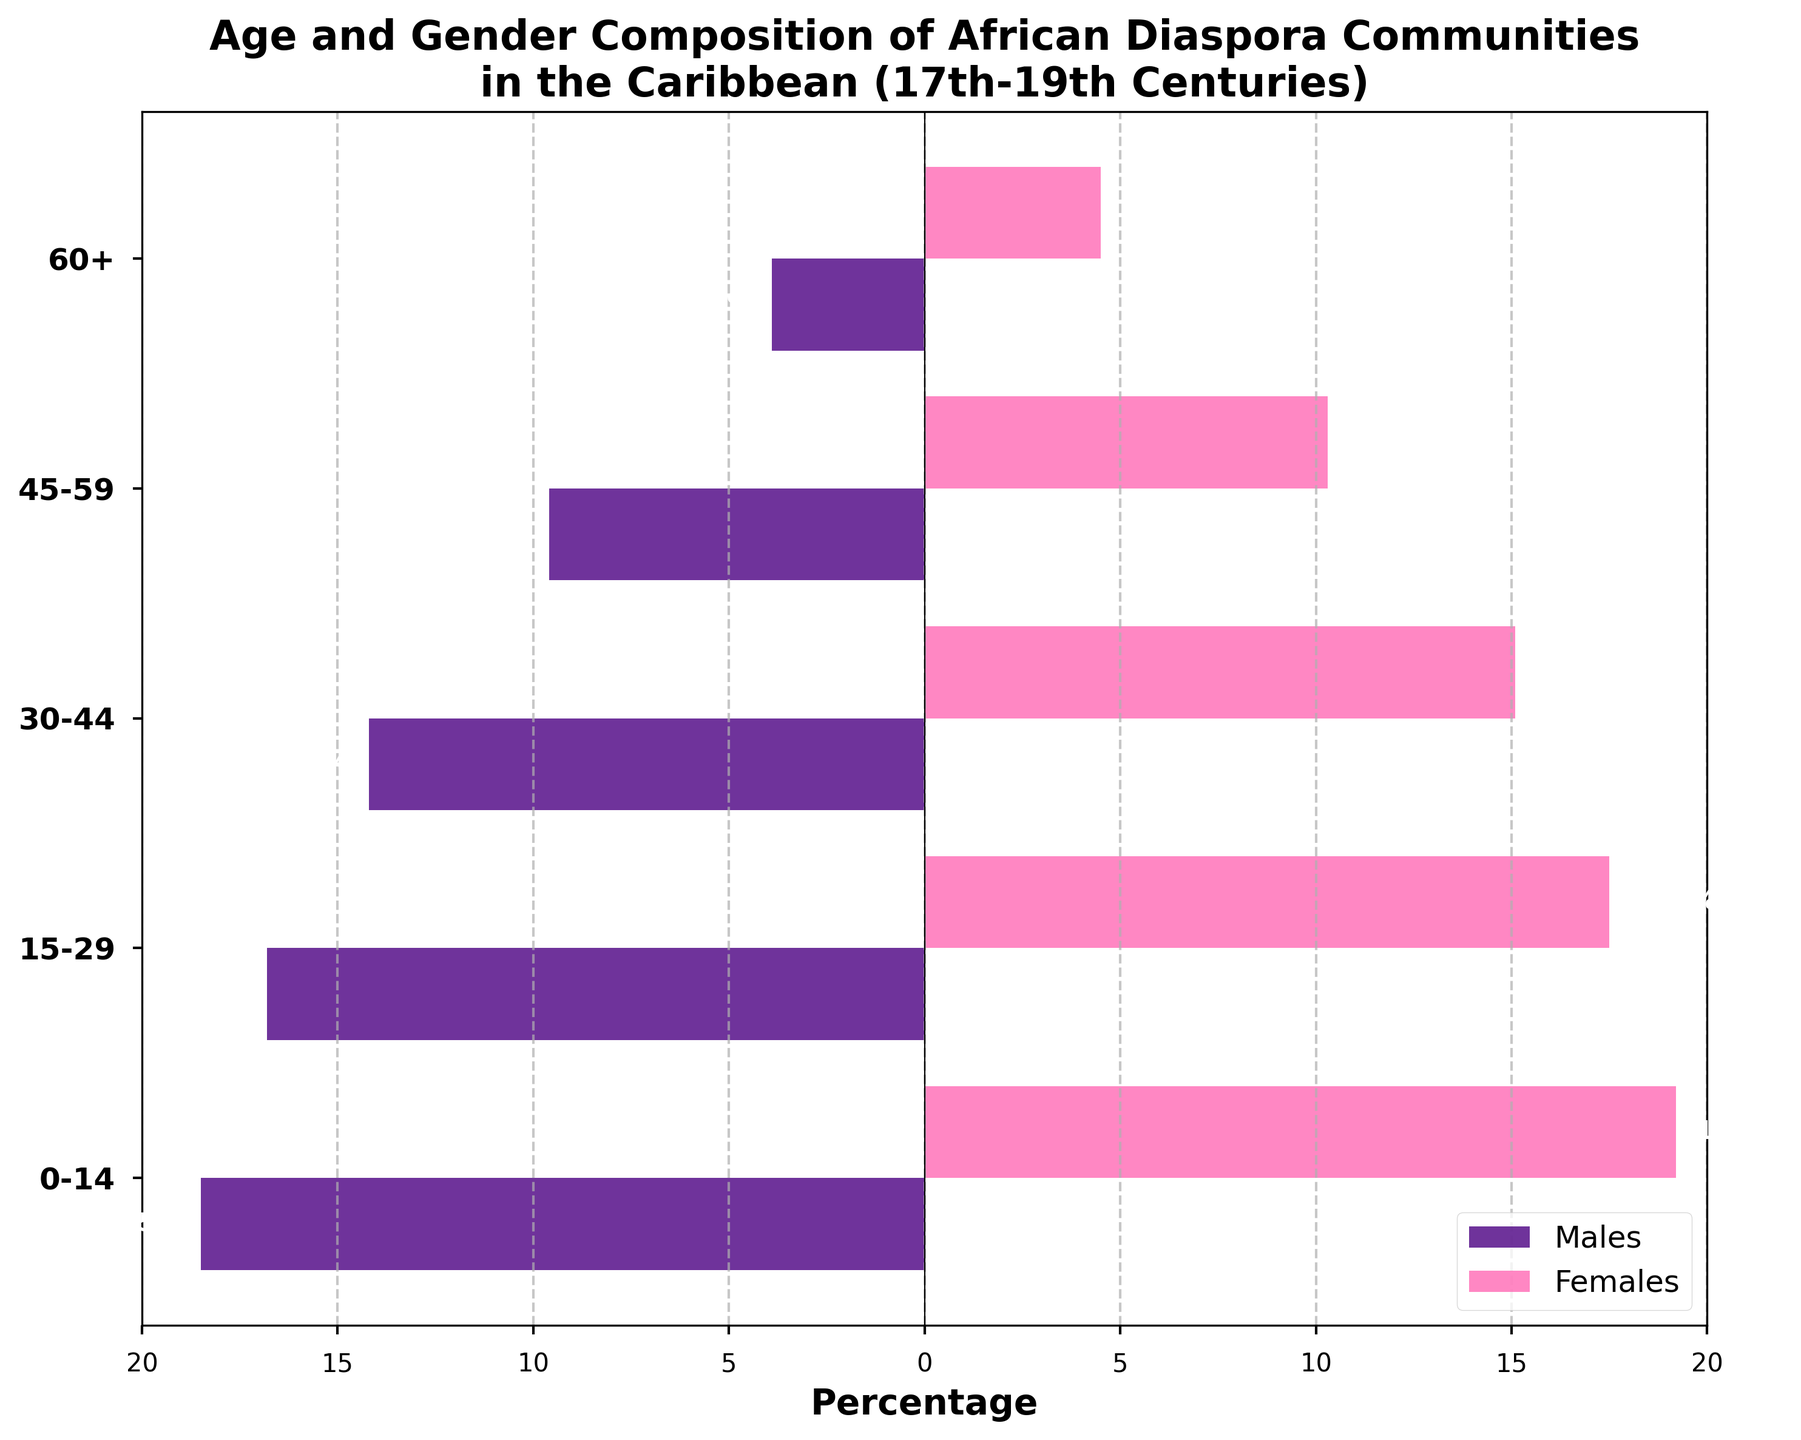What does the title of the figure indicate? The title of the figure indicates the content and scope of the data presented. Specifically, it refers to the age and gender composition of African diaspora communities in the Caribbean from the 17th to 19th centuries.
Answer: Age and gender composition of African diaspora communities in the Caribbean (17th-19th Centuries) What is the age group that has the highest percentage of females? To determine the age group with the highest percentage of females, look at the bar corresponding to females and identify the one with the longest bar. The longest bar in the female category is for the age group 0-14.
Answer: 0-14 Which gender has a higher population percentage in the 45-59 age group? Compare the bars representing males and females within the 45-59 age group. The bar for females (10.3%) is longer than that for males (9.6%).
Answer: Females What is the combined percentage of males and females in the 30-44 age group? Add the percentages of males and females in the 30-44 age group: 14.2% (males) + 15.1% (females) = 29.3%.
Answer: 29.3% Which age group has the smallest overall population percentage? The smallest combined population percentage can be found by comparing the combined length of bars for each age group. The 60+ age group has the smallest combined percentage: 3.9% (males) + 4.5% (females) = 8.4%.
Answer: 60+ How do the percentages of males and females in the 0-14 age group compare? Observe the bars representing males and females for the 0-14 age group. The percentage for females (19.2%) is slightly higher than that for males (18.5%).
Answer: Females have a higher percentage Which age group shows the most significant gender disparity? Calculate the absolute difference in percentages between males and females for each age group. The largest difference is found in the 0-14 age group:
Answer: 0-14 What is the total percentage of the population aged 15-59? First, identify and sum the percentages for the 15-29 and 30-44 age groups for both genders. For males: 16.8% (15-29) + 14.2% (30-44) + 9.6% (45-59) = 40.6%. For females: 17.5% (15-29) + 15.1% (30-44) + 10.3% (45-59) = 42.9%. 40.6% + 42.9% = 83.5%.
Answer: 83.5% What pattern can you observe about the gender distribution across age groups? When studying the bars for each age group, you'll see that females consistently have higher percentages than males across all age groups.
Answer: Females consistently have higher percentages How does the percentage of males in the 60+ age group compare to those in the 15-29 age group? Observe the lengths of the bars representing males in each of these age groups. The 60+ age group has 3.9%, whereas the 15-29 age group has 16.8%. The percentage of males in the 60+ age group is significantly lower than in the 15-29 age group.
Answer: 60+ is significantly lower 